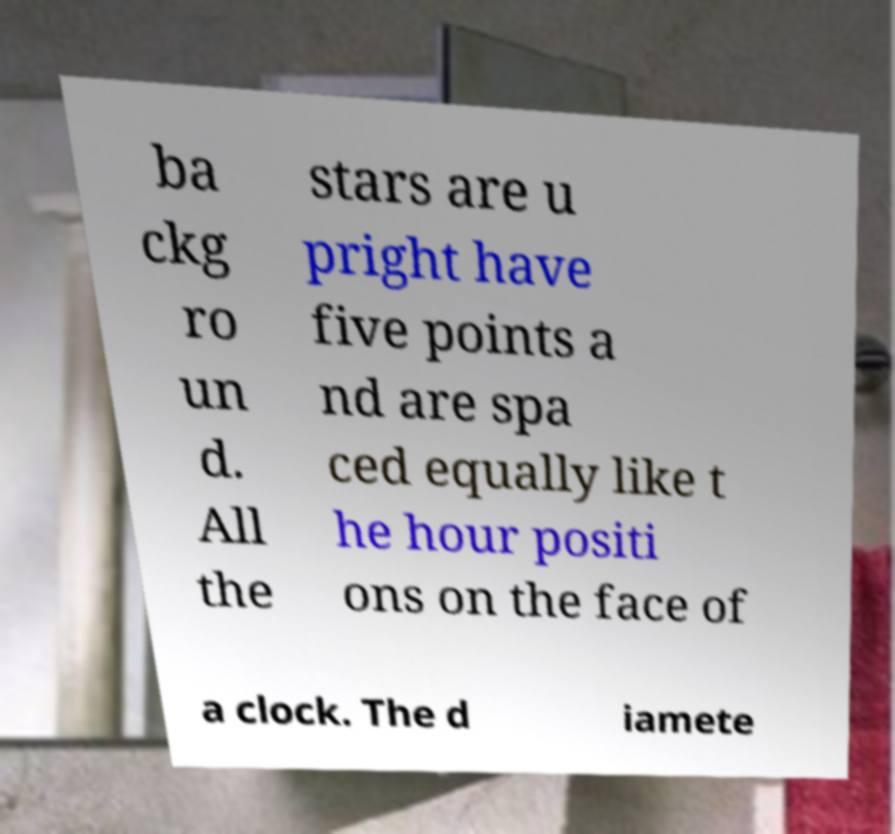What messages or text are displayed in this image? I need them in a readable, typed format. ba ckg ro un d. All the stars are u pright have five points a nd are spa ced equally like t he hour positi ons on the face of a clock. The d iamete 